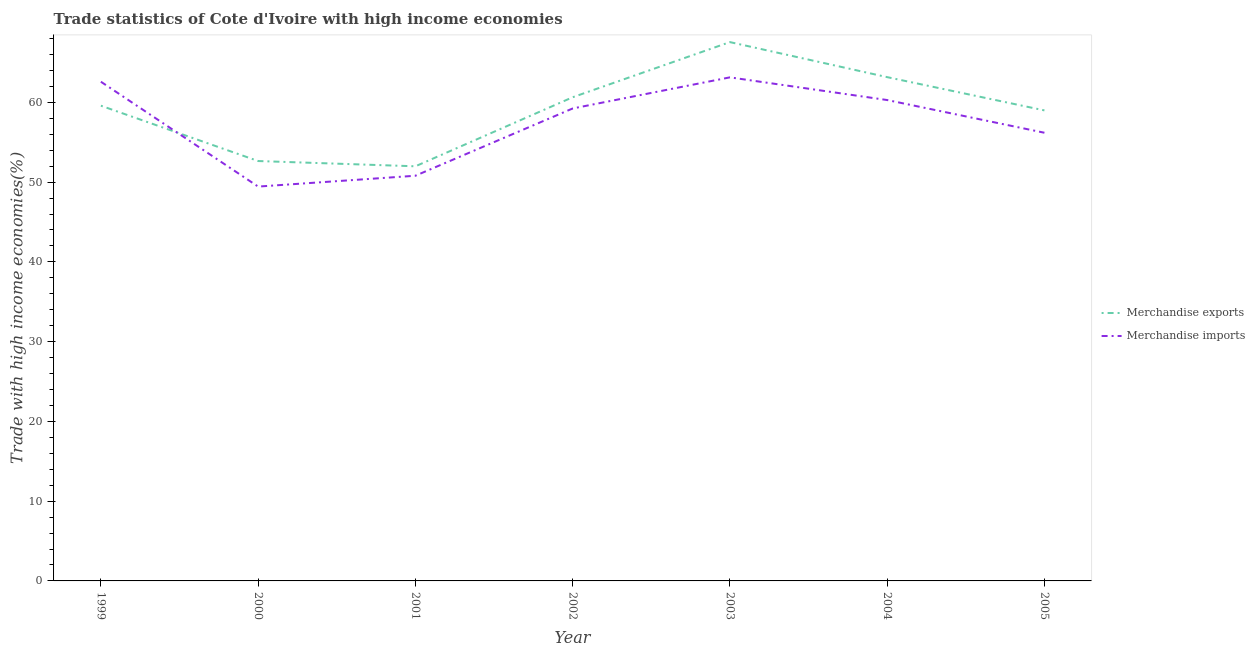How many different coloured lines are there?
Give a very brief answer. 2. What is the merchandise exports in 2005?
Offer a very short reply. 59. Across all years, what is the maximum merchandise imports?
Your response must be concise. 63.14. Across all years, what is the minimum merchandise imports?
Provide a short and direct response. 49.44. In which year was the merchandise exports maximum?
Provide a short and direct response. 2003. What is the total merchandise exports in the graph?
Your response must be concise. 414.59. What is the difference between the merchandise exports in 2001 and that in 2002?
Your answer should be very brief. -8.66. What is the difference between the merchandise imports in 2003 and the merchandise exports in 2000?
Provide a succinct answer. 10.49. What is the average merchandise exports per year?
Your answer should be compact. 59.23. In the year 2000, what is the difference between the merchandise exports and merchandise imports?
Your answer should be compact. 3.2. In how many years, is the merchandise imports greater than 50 %?
Ensure brevity in your answer.  6. What is the ratio of the merchandise imports in 2004 to that in 2005?
Provide a short and direct response. 1.07. Is the difference between the merchandise exports in 2001 and 2005 greater than the difference between the merchandise imports in 2001 and 2005?
Ensure brevity in your answer.  No. What is the difference between the highest and the second highest merchandise imports?
Make the answer very short. 0.55. What is the difference between the highest and the lowest merchandise imports?
Offer a terse response. 13.7. Does the merchandise imports monotonically increase over the years?
Your response must be concise. No. Is the merchandise exports strictly less than the merchandise imports over the years?
Your answer should be compact. No. How many lines are there?
Ensure brevity in your answer.  2. How many years are there in the graph?
Provide a succinct answer. 7. Are the values on the major ticks of Y-axis written in scientific E-notation?
Offer a very short reply. No. Where does the legend appear in the graph?
Your response must be concise. Center right. How many legend labels are there?
Your answer should be compact. 2. What is the title of the graph?
Give a very brief answer. Trade statistics of Cote d'Ivoire with high income economies. Does "Canada" appear as one of the legend labels in the graph?
Your answer should be compact. No. What is the label or title of the X-axis?
Your answer should be very brief. Year. What is the label or title of the Y-axis?
Make the answer very short. Trade with high income economies(%). What is the Trade with high income economies(%) of Merchandise exports in 1999?
Your answer should be compact. 59.59. What is the Trade with high income economies(%) in Merchandise imports in 1999?
Offer a terse response. 62.59. What is the Trade with high income economies(%) in Merchandise exports in 2000?
Keep it short and to the point. 52.65. What is the Trade with high income economies(%) of Merchandise imports in 2000?
Ensure brevity in your answer.  49.44. What is the Trade with high income economies(%) in Merchandise exports in 2001?
Your answer should be very brief. 51.99. What is the Trade with high income economies(%) in Merchandise imports in 2001?
Your answer should be compact. 50.8. What is the Trade with high income economies(%) of Merchandise exports in 2002?
Your answer should be compact. 60.65. What is the Trade with high income economies(%) of Merchandise imports in 2002?
Keep it short and to the point. 59.24. What is the Trade with high income economies(%) of Merchandise exports in 2003?
Your answer should be very brief. 67.56. What is the Trade with high income economies(%) of Merchandise imports in 2003?
Provide a short and direct response. 63.14. What is the Trade with high income economies(%) of Merchandise exports in 2004?
Keep it short and to the point. 63.17. What is the Trade with high income economies(%) in Merchandise imports in 2004?
Ensure brevity in your answer.  60.3. What is the Trade with high income economies(%) of Merchandise exports in 2005?
Make the answer very short. 59. What is the Trade with high income economies(%) in Merchandise imports in 2005?
Keep it short and to the point. 56.19. Across all years, what is the maximum Trade with high income economies(%) in Merchandise exports?
Give a very brief answer. 67.56. Across all years, what is the maximum Trade with high income economies(%) of Merchandise imports?
Your answer should be very brief. 63.14. Across all years, what is the minimum Trade with high income economies(%) in Merchandise exports?
Your answer should be very brief. 51.99. Across all years, what is the minimum Trade with high income economies(%) of Merchandise imports?
Your answer should be compact. 49.44. What is the total Trade with high income economies(%) in Merchandise exports in the graph?
Provide a succinct answer. 414.59. What is the total Trade with high income economies(%) of Merchandise imports in the graph?
Offer a very short reply. 401.7. What is the difference between the Trade with high income economies(%) in Merchandise exports in 1999 and that in 2000?
Your answer should be very brief. 6.94. What is the difference between the Trade with high income economies(%) in Merchandise imports in 1999 and that in 2000?
Keep it short and to the point. 13.15. What is the difference between the Trade with high income economies(%) of Merchandise exports in 1999 and that in 2001?
Provide a short and direct response. 7.6. What is the difference between the Trade with high income economies(%) of Merchandise imports in 1999 and that in 2001?
Provide a short and direct response. 11.79. What is the difference between the Trade with high income economies(%) of Merchandise exports in 1999 and that in 2002?
Your answer should be compact. -1.06. What is the difference between the Trade with high income economies(%) in Merchandise imports in 1999 and that in 2002?
Your answer should be compact. 3.35. What is the difference between the Trade with high income economies(%) of Merchandise exports in 1999 and that in 2003?
Provide a short and direct response. -7.97. What is the difference between the Trade with high income economies(%) in Merchandise imports in 1999 and that in 2003?
Keep it short and to the point. -0.55. What is the difference between the Trade with high income economies(%) of Merchandise exports in 1999 and that in 2004?
Keep it short and to the point. -3.58. What is the difference between the Trade with high income economies(%) in Merchandise imports in 1999 and that in 2004?
Provide a short and direct response. 2.3. What is the difference between the Trade with high income economies(%) in Merchandise exports in 1999 and that in 2005?
Ensure brevity in your answer.  0.59. What is the difference between the Trade with high income economies(%) of Merchandise imports in 1999 and that in 2005?
Ensure brevity in your answer.  6.4. What is the difference between the Trade with high income economies(%) of Merchandise exports in 2000 and that in 2001?
Make the answer very short. 0.66. What is the difference between the Trade with high income economies(%) of Merchandise imports in 2000 and that in 2001?
Your answer should be very brief. -1.36. What is the difference between the Trade with high income economies(%) of Merchandise exports in 2000 and that in 2002?
Offer a very short reply. -8. What is the difference between the Trade with high income economies(%) in Merchandise imports in 2000 and that in 2002?
Provide a short and direct response. -9.79. What is the difference between the Trade with high income economies(%) of Merchandise exports in 2000 and that in 2003?
Your answer should be very brief. -14.91. What is the difference between the Trade with high income economies(%) in Merchandise imports in 2000 and that in 2003?
Your answer should be very brief. -13.7. What is the difference between the Trade with high income economies(%) of Merchandise exports in 2000 and that in 2004?
Keep it short and to the point. -10.52. What is the difference between the Trade with high income economies(%) of Merchandise imports in 2000 and that in 2004?
Your answer should be compact. -10.85. What is the difference between the Trade with high income economies(%) of Merchandise exports in 2000 and that in 2005?
Your answer should be compact. -6.35. What is the difference between the Trade with high income economies(%) of Merchandise imports in 2000 and that in 2005?
Your answer should be very brief. -6.75. What is the difference between the Trade with high income economies(%) of Merchandise exports in 2001 and that in 2002?
Your response must be concise. -8.66. What is the difference between the Trade with high income economies(%) in Merchandise imports in 2001 and that in 2002?
Your answer should be compact. -8.43. What is the difference between the Trade with high income economies(%) in Merchandise exports in 2001 and that in 2003?
Provide a succinct answer. -15.57. What is the difference between the Trade with high income economies(%) of Merchandise imports in 2001 and that in 2003?
Make the answer very short. -12.34. What is the difference between the Trade with high income economies(%) of Merchandise exports in 2001 and that in 2004?
Your answer should be very brief. -11.18. What is the difference between the Trade with high income economies(%) in Merchandise imports in 2001 and that in 2004?
Give a very brief answer. -9.49. What is the difference between the Trade with high income economies(%) of Merchandise exports in 2001 and that in 2005?
Keep it short and to the point. -7.01. What is the difference between the Trade with high income economies(%) in Merchandise imports in 2001 and that in 2005?
Keep it short and to the point. -5.39. What is the difference between the Trade with high income economies(%) of Merchandise exports in 2002 and that in 2003?
Your response must be concise. -6.91. What is the difference between the Trade with high income economies(%) of Merchandise imports in 2002 and that in 2003?
Ensure brevity in your answer.  -3.9. What is the difference between the Trade with high income economies(%) in Merchandise exports in 2002 and that in 2004?
Your answer should be compact. -2.52. What is the difference between the Trade with high income economies(%) in Merchandise imports in 2002 and that in 2004?
Provide a short and direct response. -1.06. What is the difference between the Trade with high income economies(%) in Merchandise exports in 2002 and that in 2005?
Ensure brevity in your answer.  1.65. What is the difference between the Trade with high income economies(%) of Merchandise imports in 2002 and that in 2005?
Offer a very short reply. 3.04. What is the difference between the Trade with high income economies(%) of Merchandise exports in 2003 and that in 2004?
Keep it short and to the point. 4.39. What is the difference between the Trade with high income economies(%) in Merchandise imports in 2003 and that in 2004?
Give a very brief answer. 2.84. What is the difference between the Trade with high income economies(%) of Merchandise exports in 2003 and that in 2005?
Give a very brief answer. 8.56. What is the difference between the Trade with high income economies(%) of Merchandise imports in 2003 and that in 2005?
Your answer should be compact. 6.94. What is the difference between the Trade with high income economies(%) in Merchandise exports in 2004 and that in 2005?
Your answer should be compact. 4.17. What is the difference between the Trade with high income economies(%) of Merchandise imports in 2004 and that in 2005?
Make the answer very short. 4.1. What is the difference between the Trade with high income economies(%) in Merchandise exports in 1999 and the Trade with high income economies(%) in Merchandise imports in 2000?
Keep it short and to the point. 10.14. What is the difference between the Trade with high income economies(%) of Merchandise exports in 1999 and the Trade with high income economies(%) of Merchandise imports in 2001?
Make the answer very short. 8.78. What is the difference between the Trade with high income economies(%) in Merchandise exports in 1999 and the Trade with high income economies(%) in Merchandise imports in 2002?
Offer a very short reply. 0.35. What is the difference between the Trade with high income economies(%) in Merchandise exports in 1999 and the Trade with high income economies(%) in Merchandise imports in 2003?
Your answer should be compact. -3.55. What is the difference between the Trade with high income economies(%) in Merchandise exports in 1999 and the Trade with high income economies(%) in Merchandise imports in 2004?
Offer a very short reply. -0.71. What is the difference between the Trade with high income economies(%) of Merchandise exports in 1999 and the Trade with high income economies(%) of Merchandise imports in 2005?
Ensure brevity in your answer.  3.39. What is the difference between the Trade with high income economies(%) of Merchandise exports in 2000 and the Trade with high income economies(%) of Merchandise imports in 2001?
Keep it short and to the point. 1.85. What is the difference between the Trade with high income economies(%) of Merchandise exports in 2000 and the Trade with high income economies(%) of Merchandise imports in 2002?
Your response must be concise. -6.59. What is the difference between the Trade with high income economies(%) in Merchandise exports in 2000 and the Trade with high income economies(%) in Merchandise imports in 2003?
Your answer should be compact. -10.49. What is the difference between the Trade with high income economies(%) of Merchandise exports in 2000 and the Trade with high income economies(%) of Merchandise imports in 2004?
Make the answer very short. -7.65. What is the difference between the Trade with high income economies(%) of Merchandise exports in 2000 and the Trade with high income economies(%) of Merchandise imports in 2005?
Give a very brief answer. -3.55. What is the difference between the Trade with high income economies(%) of Merchandise exports in 2001 and the Trade with high income economies(%) of Merchandise imports in 2002?
Your response must be concise. -7.25. What is the difference between the Trade with high income economies(%) in Merchandise exports in 2001 and the Trade with high income economies(%) in Merchandise imports in 2003?
Keep it short and to the point. -11.15. What is the difference between the Trade with high income economies(%) of Merchandise exports in 2001 and the Trade with high income economies(%) of Merchandise imports in 2004?
Your answer should be compact. -8.31. What is the difference between the Trade with high income economies(%) of Merchandise exports in 2001 and the Trade with high income economies(%) of Merchandise imports in 2005?
Offer a very short reply. -4.21. What is the difference between the Trade with high income economies(%) in Merchandise exports in 2002 and the Trade with high income economies(%) in Merchandise imports in 2003?
Provide a short and direct response. -2.49. What is the difference between the Trade with high income economies(%) in Merchandise exports in 2002 and the Trade with high income economies(%) in Merchandise imports in 2005?
Your answer should be very brief. 4.45. What is the difference between the Trade with high income economies(%) of Merchandise exports in 2003 and the Trade with high income economies(%) of Merchandise imports in 2004?
Provide a succinct answer. 7.26. What is the difference between the Trade with high income economies(%) of Merchandise exports in 2003 and the Trade with high income economies(%) of Merchandise imports in 2005?
Give a very brief answer. 11.36. What is the difference between the Trade with high income economies(%) in Merchandise exports in 2004 and the Trade with high income economies(%) in Merchandise imports in 2005?
Your response must be concise. 6.97. What is the average Trade with high income economies(%) in Merchandise exports per year?
Offer a very short reply. 59.23. What is the average Trade with high income economies(%) in Merchandise imports per year?
Your answer should be very brief. 57.39. In the year 1999, what is the difference between the Trade with high income economies(%) in Merchandise exports and Trade with high income economies(%) in Merchandise imports?
Your answer should be very brief. -3.01. In the year 2000, what is the difference between the Trade with high income economies(%) of Merchandise exports and Trade with high income economies(%) of Merchandise imports?
Make the answer very short. 3.2. In the year 2001, what is the difference between the Trade with high income economies(%) of Merchandise exports and Trade with high income economies(%) of Merchandise imports?
Your response must be concise. 1.18. In the year 2002, what is the difference between the Trade with high income economies(%) of Merchandise exports and Trade with high income economies(%) of Merchandise imports?
Your response must be concise. 1.41. In the year 2003, what is the difference between the Trade with high income economies(%) in Merchandise exports and Trade with high income economies(%) in Merchandise imports?
Your response must be concise. 4.42. In the year 2004, what is the difference between the Trade with high income economies(%) in Merchandise exports and Trade with high income economies(%) in Merchandise imports?
Your answer should be very brief. 2.87. In the year 2005, what is the difference between the Trade with high income economies(%) in Merchandise exports and Trade with high income economies(%) in Merchandise imports?
Provide a short and direct response. 2.8. What is the ratio of the Trade with high income economies(%) in Merchandise exports in 1999 to that in 2000?
Offer a terse response. 1.13. What is the ratio of the Trade with high income economies(%) of Merchandise imports in 1999 to that in 2000?
Ensure brevity in your answer.  1.27. What is the ratio of the Trade with high income economies(%) of Merchandise exports in 1999 to that in 2001?
Make the answer very short. 1.15. What is the ratio of the Trade with high income economies(%) of Merchandise imports in 1999 to that in 2001?
Your response must be concise. 1.23. What is the ratio of the Trade with high income economies(%) in Merchandise exports in 1999 to that in 2002?
Your answer should be compact. 0.98. What is the ratio of the Trade with high income economies(%) of Merchandise imports in 1999 to that in 2002?
Keep it short and to the point. 1.06. What is the ratio of the Trade with high income economies(%) in Merchandise exports in 1999 to that in 2003?
Provide a succinct answer. 0.88. What is the ratio of the Trade with high income economies(%) in Merchandise imports in 1999 to that in 2003?
Offer a very short reply. 0.99. What is the ratio of the Trade with high income economies(%) in Merchandise exports in 1999 to that in 2004?
Your answer should be compact. 0.94. What is the ratio of the Trade with high income economies(%) of Merchandise imports in 1999 to that in 2004?
Give a very brief answer. 1.04. What is the ratio of the Trade with high income economies(%) of Merchandise exports in 1999 to that in 2005?
Ensure brevity in your answer.  1.01. What is the ratio of the Trade with high income economies(%) in Merchandise imports in 1999 to that in 2005?
Your answer should be very brief. 1.11. What is the ratio of the Trade with high income economies(%) in Merchandise exports in 2000 to that in 2001?
Offer a very short reply. 1.01. What is the ratio of the Trade with high income economies(%) of Merchandise imports in 2000 to that in 2001?
Provide a short and direct response. 0.97. What is the ratio of the Trade with high income economies(%) in Merchandise exports in 2000 to that in 2002?
Offer a terse response. 0.87. What is the ratio of the Trade with high income economies(%) of Merchandise imports in 2000 to that in 2002?
Provide a short and direct response. 0.83. What is the ratio of the Trade with high income economies(%) of Merchandise exports in 2000 to that in 2003?
Offer a terse response. 0.78. What is the ratio of the Trade with high income economies(%) in Merchandise imports in 2000 to that in 2003?
Make the answer very short. 0.78. What is the ratio of the Trade with high income economies(%) in Merchandise exports in 2000 to that in 2004?
Keep it short and to the point. 0.83. What is the ratio of the Trade with high income economies(%) of Merchandise imports in 2000 to that in 2004?
Provide a succinct answer. 0.82. What is the ratio of the Trade with high income economies(%) in Merchandise exports in 2000 to that in 2005?
Keep it short and to the point. 0.89. What is the ratio of the Trade with high income economies(%) in Merchandise imports in 2000 to that in 2005?
Your answer should be compact. 0.88. What is the ratio of the Trade with high income economies(%) in Merchandise exports in 2001 to that in 2002?
Your response must be concise. 0.86. What is the ratio of the Trade with high income economies(%) of Merchandise imports in 2001 to that in 2002?
Keep it short and to the point. 0.86. What is the ratio of the Trade with high income economies(%) in Merchandise exports in 2001 to that in 2003?
Make the answer very short. 0.77. What is the ratio of the Trade with high income economies(%) in Merchandise imports in 2001 to that in 2003?
Give a very brief answer. 0.8. What is the ratio of the Trade with high income economies(%) in Merchandise exports in 2001 to that in 2004?
Keep it short and to the point. 0.82. What is the ratio of the Trade with high income economies(%) of Merchandise imports in 2001 to that in 2004?
Make the answer very short. 0.84. What is the ratio of the Trade with high income economies(%) in Merchandise exports in 2001 to that in 2005?
Offer a very short reply. 0.88. What is the ratio of the Trade with high income economies(%) of Merchandise imports in 2001 to that in 2005?
Offer a very short reply. 0.9. What is the ratio of the Trade with high income economies(%) of Merchandise exports in 2002 to that in 2003?
Provide a succinct answer. 0.9. What is the ratio of the Trade with high income economies(%) in Merchandise imports in 2002 to that in 2003?
Your answer should be very brief. 0.94. What is the ratio of the Trade with high income economies(%) of Merchandise exports in 2002 to that in 2004?
Ensure brevity in your answer.  0.96. What is the ratio of the Trade with high income economies(%) in Merchandise imports in 2002 to that in 2004?
Give a very brief answer. 0.98. What is the ratio of the Trade with high income economies(%) in Merchandise exports in 2002 to that in 2005?
Keep it short and to the point. 1.03. What is the ratio of the Trade with high income economies(%) in Merchandise imports in 2002 to that in 2005?
Offer a very short reply. 1.05. What is the ratio of the Trade with high income economies(%) of Merchandise exports in 2003 to that in 2004?
Your answer should be very brief. 1.07. What is the ratio of the Trade with high income economies(%) in Merchandise imports in 2003 to that in 2004?
Give a very brief answer. 1.05. What is the ratio of the Trade with high income economies(%) in Merchandise exports in 2003 to that in 2005?
Provide a succinct answer. 1.15. What is the ratio of the Trade with high income economies(%) in Merchandise imports in 2003 to that in 2005?
Offer a terse response. 1.12. What is the ratio of the Trade with high income economies(%) of Merchandise exports in 2004 to that in 2005?
Ensure brevity in your answer.  1.07. What is the ratio of the Trade with high income economies(%) of Merchandise imports in 2004 to that in 2005?
Your response must be concise. 1.07. What is the difference between the highest and the second highest Trade with high income economies(%) in Merchandise exports?
Ensure brevity in your answer.  4.39. What is the difference between the highest and the second highest Trade with high income economies(%) in Merchandise imports?
Offer a terse response. 0.55. What is the difference between the highest and the lowest Trade with high income economies(%) in Merchandise exports?
Provide a short and direct response. 15.57. What is the difference between the highest and the lowest Trade with high income economies(%) of Merchandise imports?
Your answer should be compact. 13.7. 